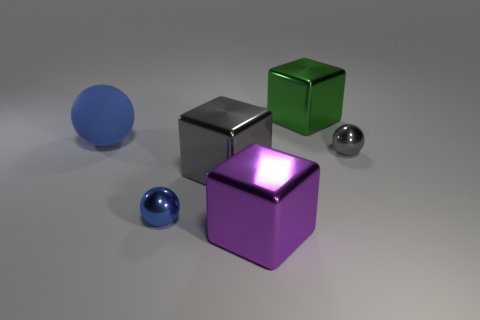Add 2 red shiny cylinders. How many objects exist? 8 Subtract all large brown matte cylinders. Subtract all large blue balls. How many objects are left? 5 Add 4 gray things. How many gray things are left? 6 Add 2 big gray blocks. How many big gray blocks exist? 3 Subtract 0 brown cylinders. How many objects are left? 6 